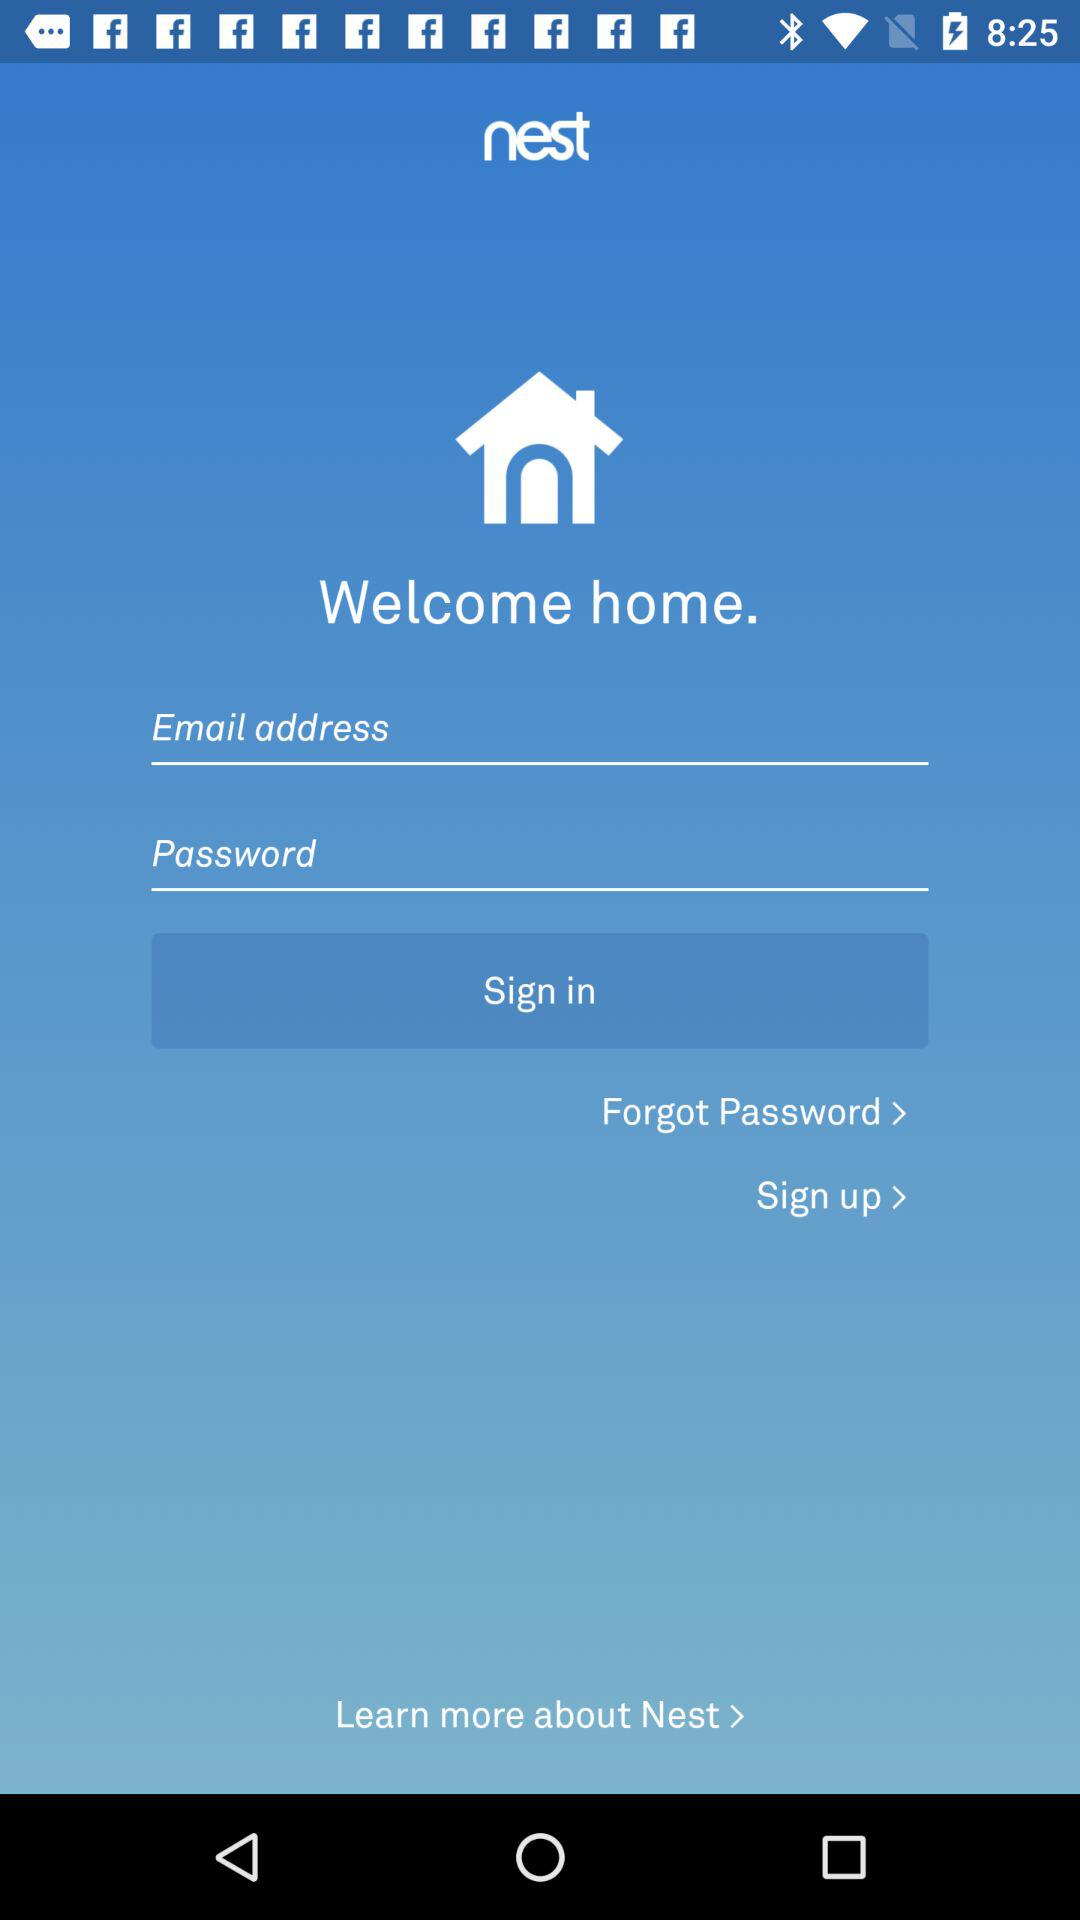What is the application name? The application name is "nest". 